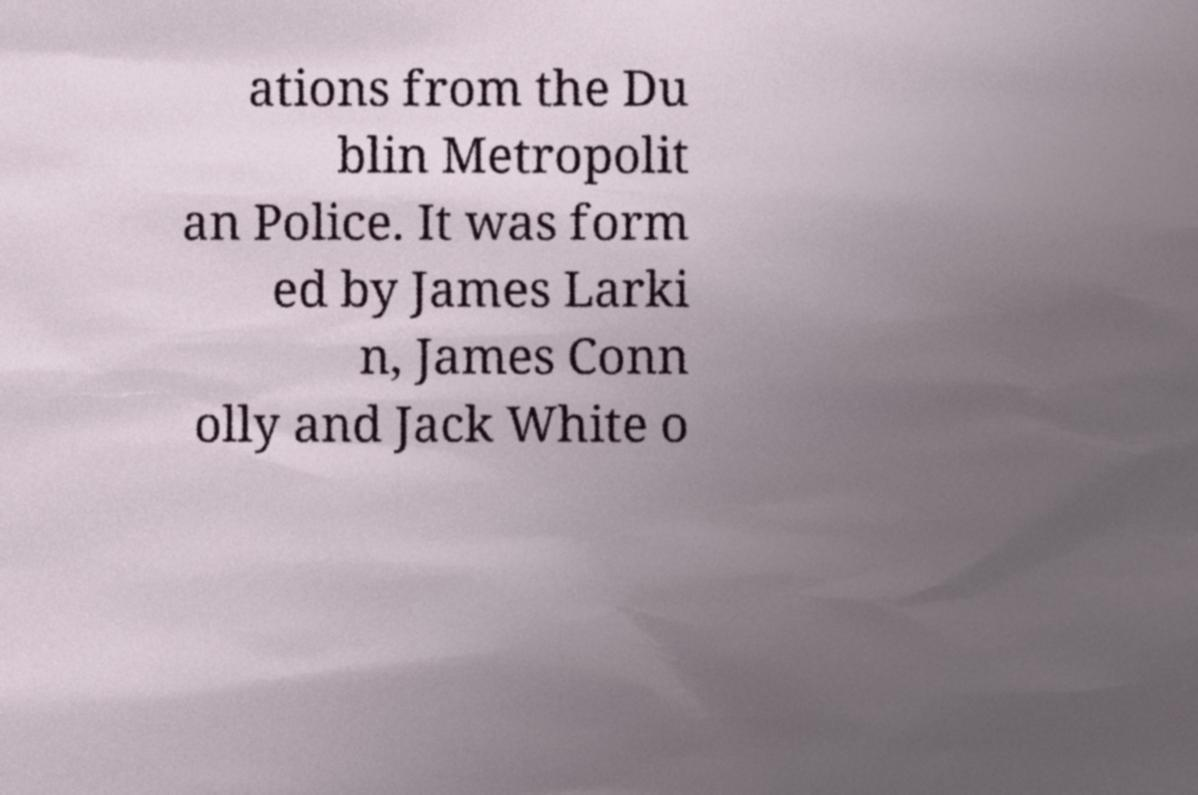Can you accurately transcribe the text from the provided image for me? ations from the Du blin Metropolit an Police. It was form ed by James Larki n, James Conn olly and Jack White o 